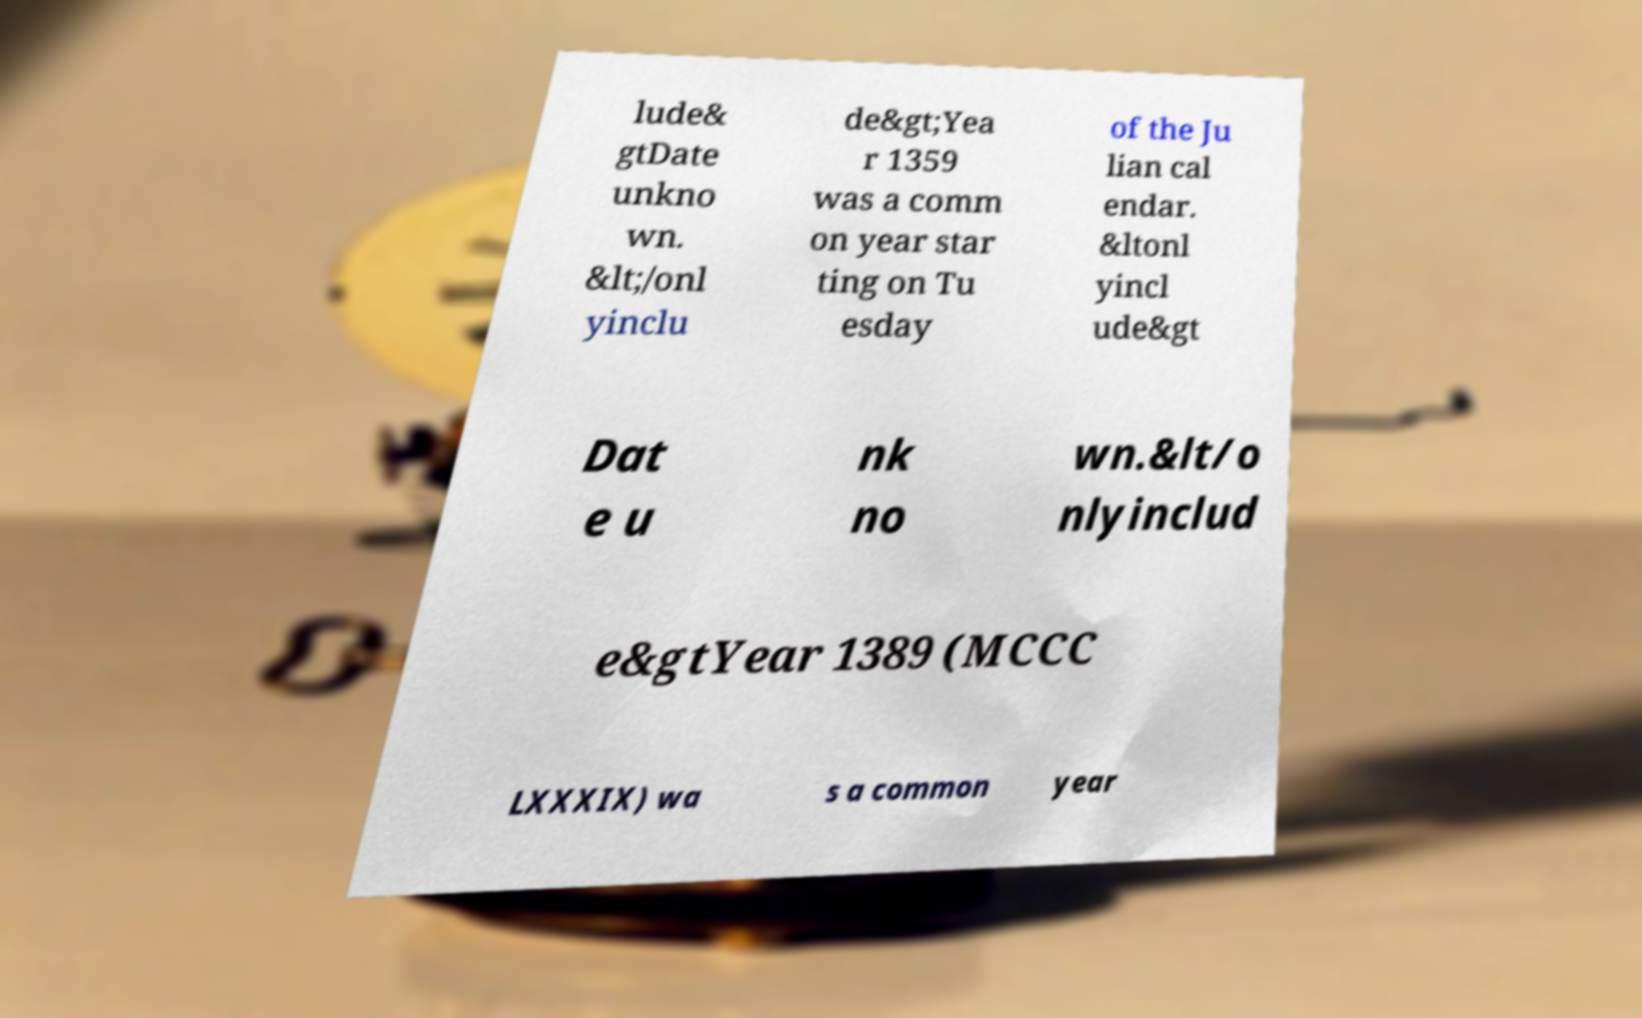Could you extract and type out the text from this image? lude& gtDate unkno wn. &lt;/onl yinclu de&gt;Yea r 1359 was a comm on year star ting on Tu esday of the Ju lian cal endar. &ltonl yincl ude&gt Dat e u nk no wn.&lt/o nlyinclud e&gtYear 1389 (MCCC LXXXIX) wa s a common year 